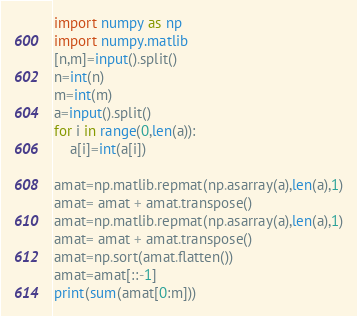Convert code to text. <code><loc_0><loc_0><loc_500><loc_500><_Python_>import numpy as np
import numpy.matlib
[n,m]=input().split()
n=int(n)
m=int(m)
a=input().split()
for i in range(0,len(a)):
    a[i]=int(a[i])

amat=np.matlib.repmat(np.asarray(a),len(a),1)
amat= amat + amat.transpose()
amat=np.matlib.repmat(np.asarray(a),len(a),1)
amat= amat + amat.transpose()
amat=np.sort(amat.flatten())
amat=amat[::-1]
print(sum(amat[0:m]))</code> 